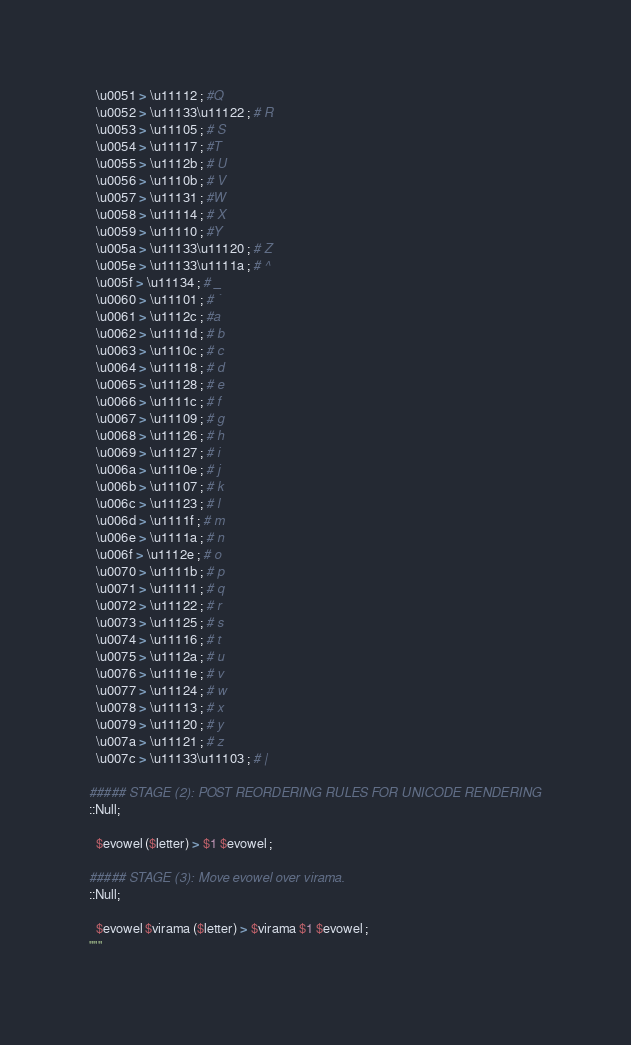Convert code to text. <code><loc_0><loc_0><loc_500><loc_500><_Python_>  \u0051 > \u11112 ; #Q
  \u0052 > \u11133\u11122 ; # R
  \u0053 > \u11105 ; # S
  \u0054 > \u11117 ; #T
  \u0055 > \u1112b ; # U
  \u0056 > \u1110b ; # V
  \u0057 > \u11131 ; #W
  \u0058 > \u11114 ; # X
  \u0059 > \u11110 ; #Y
  \u005a > \u11133\u11120 ; # Z
  \u005e > \u11133\u1111a ; # ^
  \u005f > \u11134 ; # _
  \u0060 > \u11101 ; # `
  \u0061 > \u1112c ; #a
  \u0062 > \u1111d ; # b
  \u0063 > \u1110c ; # c
  \u0064 > \u11118 ; # d
  \u0065 > \u11128 ; # e
  \u0066 > \u1111c ; # f
  \u0067 > \u11109 ; # g
  \u0068 > \u11126 ; # h
  \u0069 > \u11127 ; # i
  \u006a > \u1110e ; # j
  \u006b > \u11107 ; # k
  \u006c > \u11123 ; # l
  \u006d > \u1111f ; # m
  \u006e > \u1111a ; # n
  \u006f > \u1112e ; # o
  \u0070 > \u1111b ; # p
  \u0071 > \u11111 ; # q
  \u0072 > \u11122 ; # r
  \u0073 > \u11125 ; # s
  \u0074 > \u11116 ; # t
  \u0075 > \u1112a ; # u
  \u0076 > \u1111e ; # v
  \u0077 > \u11124 ; # w
  \u0078 > \u11113 ; # x
  \u0079 > \u11120 ; # y
  \u007a > \u11121 ; # z
  \u007c > \u11133\u11103 ; # |

##### STAGE (2): POST REORDERING RULES FOR UNICODE RENDERING
::Null;

  $evowel ($letter) > $1 $evowel ;

##### STAGE (3): Move evowel over virama.
::Null;

  $evowel $virama ($letter) > $virama $1 $evowel ;
"""
</code> 